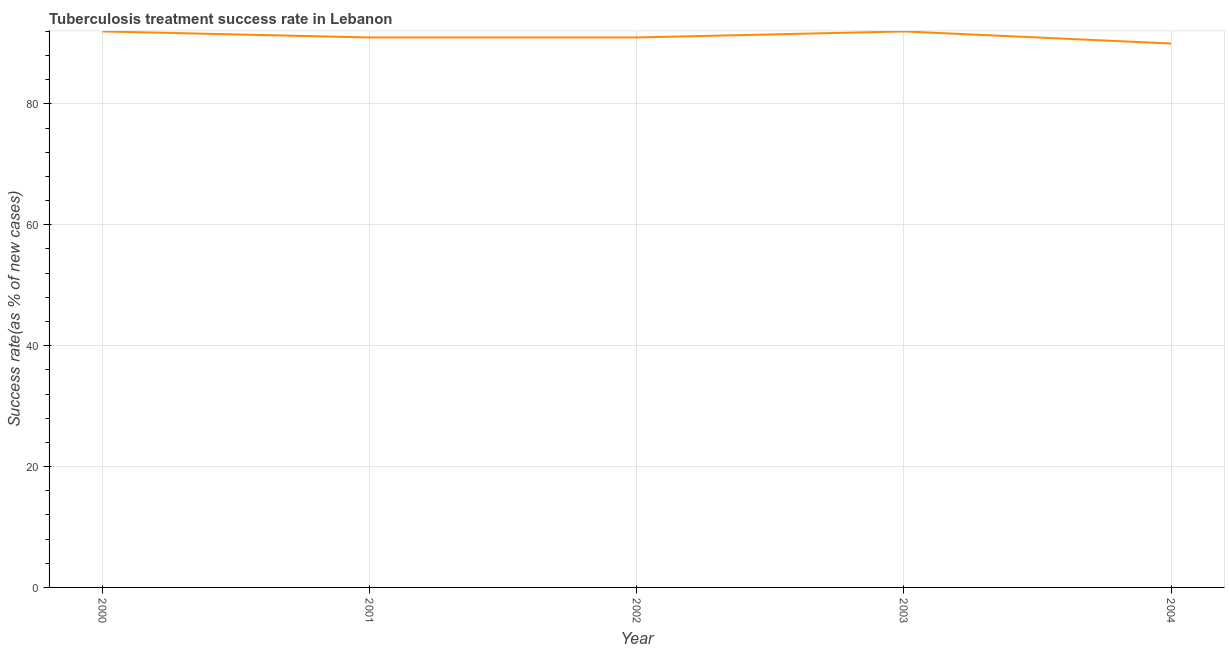What is the tuberculosis treatment success rate in 2003?
Keep it short and to the point. 92. Across all years, what is the maximum tuberculosis treatment success rate?
Your answer should be compact. 92. Across all years, what is the minimum tuberculosis treatment success rate?
Your answer should be very brief. 90. In which year was the tuberculosis treatment success rate minimum?
Your answer should be very brief. 2004. What is the sum of the tuberculosis treatment success rate?
Offer a terse response. 456. What is the difference between the tuberculosis treatment success rate in 2001 and 2004?
Provide a succinct answer. 1. What is the average tuberculosis treatment success rate per year?
Provide a short and direct response. 91.2. What is the median tuberculosis treatment success rate?
Your answer should be compact. 91. Do a majority of the years between 2001 and 2002 (inclusive) have tuberculosis treatment success rate greater than 32 %?
Make the answer very short. Yes. What is the ratio of the tuberculosis treatment success rate in 2000 to that in 2004?
Ensure brevity in your answer.  1.02. Is the tuberculosis treatment success rate in 2000 less than that in 2001?
Make the answer very short. No. What is the difference between the highest and the second highest tuberculosis treatment success rate?
Provide a succinct answer. 0. What is the difference between the highest and the lowest tuberculosis treatment success rate?
Provide a succinct answer. 2. How many years are there in the graph?
Your answer should be compact. 5. Are the values on the major ticks of Y-axis written in scientific E-notation?
Offer a terse response. No. Does the graph contain any zero values?
Provide a succinct answer. No. Does the graph contain grids?
Offer a terse response. Yes. What is the title of the graph?
Keep it short and to the point. Tuberculosis treatment success rate in Lebanon. What is the label or title of the X-axis?
Provide a short and direct response. Year. What is the label or title of the Y-axis?
Ensure brevity in your answer.  Success rate(as % of new cases). What is the Success rate(as % of new cases) in 2000?
Your answer should be compact. 92. What is the Success rate(as % of new cases) in 2001?
Your answer should be compact. 91. What is the Success rate(as % of new cases) of 2002?
Make the answer very short. 91. What is the Success rate(as % of new cases) of 2003?
Make the answer very short. 92. What is the Success rate(as % of new cases) in 2004?
Offer a terse response. 90. What is the difference between the Success rate(as % of new cases) in 2000 and 2001?
Offer a very short reply. 1. What is the difference between the Success rate(as % of new cases) in 2000 and 2003?
Offer a very short reply. 0. What is the difference between the Success rate(as % of new cases) in 2002 and 2003?
Provide a succinct answer. -1. What is the difference between the Success rate(as % of new cases) in 2002 and 2004?
Keep it short and to the point. 1. What is the difference between the Success rate(as % of new cases) in 2003 and 2004?
Your answer should be compact. 2. What is the ratio of the Success rate(as % of new cases) in 2001 to that in 2004?
Ensure brevity in your answer.  1.01. What is the ratio of the Success rate(as % of new cases) in 2002 to that in 2003?
Provide a succinct answer. 0.99. 